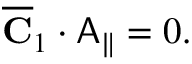<formula> <loc_0><loc_0><loc_500><loc_500>\begin{array} { r } { \overline { C } _ { 1 } \cdot A _ { \| } = 0 . } \end{array}</formula> 